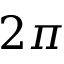Convert formula to latex. <formula><loc_0><loc_0><loc_500><loc_500>2 \pi</formula> 